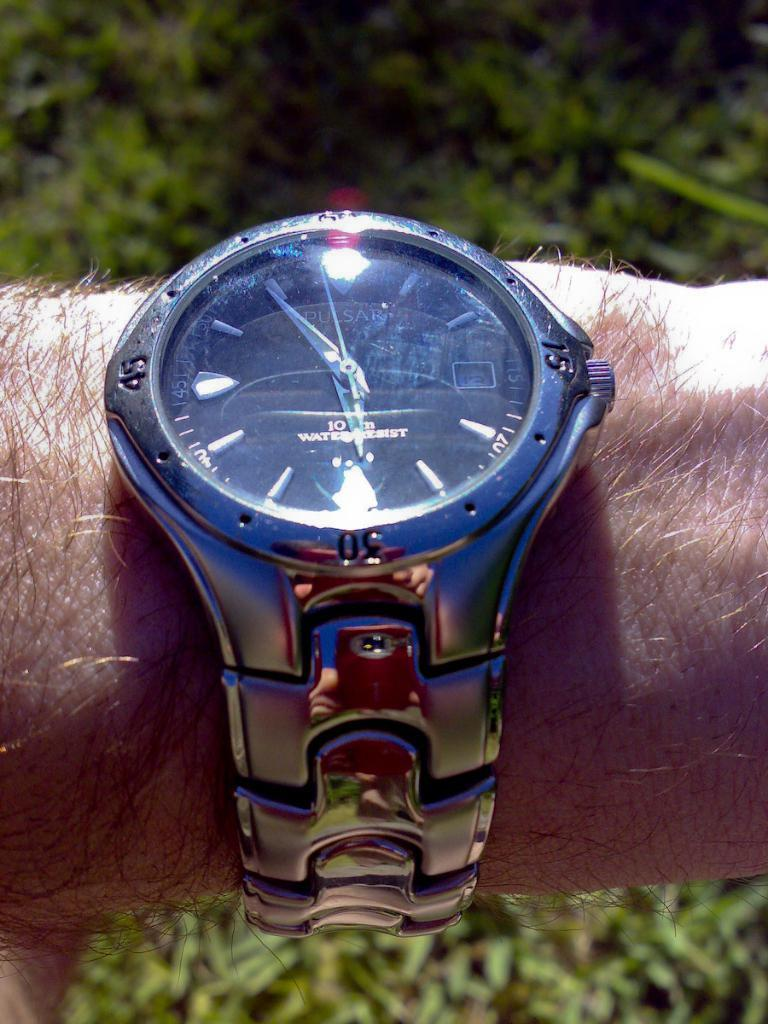<image>
Relay a brief, clear account of the picture shown. A man has a Pulsar watch on his wrist. 